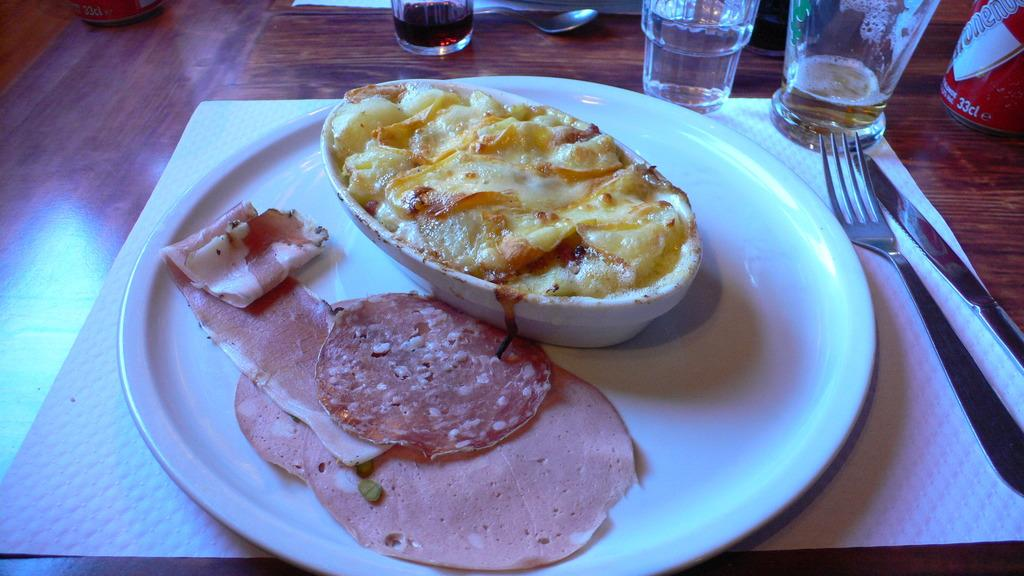What is on the plate in the image? There are food items on a plate in the image. What is in the bowl in the image? There are food items in a bowl in the image. What type of containers are present in the image? There are tins in the image. What type of tableware is present in the image? There are glasses, a spoon, a knife, and a fork in the image. What else can be seen on the table in the image? There are papers on the table in the image. What type of acoustics can be heard in the image? There is no audible sound in the image, so it is not possible to determine the acoustics. What type of tin is visible in the image? The provided facts do not specify the type of tin, only that there are tins present in the image. Can you see the moon in the image? The moon is not visible in the image; it is focused on food items, tableware, and papers on a table. 